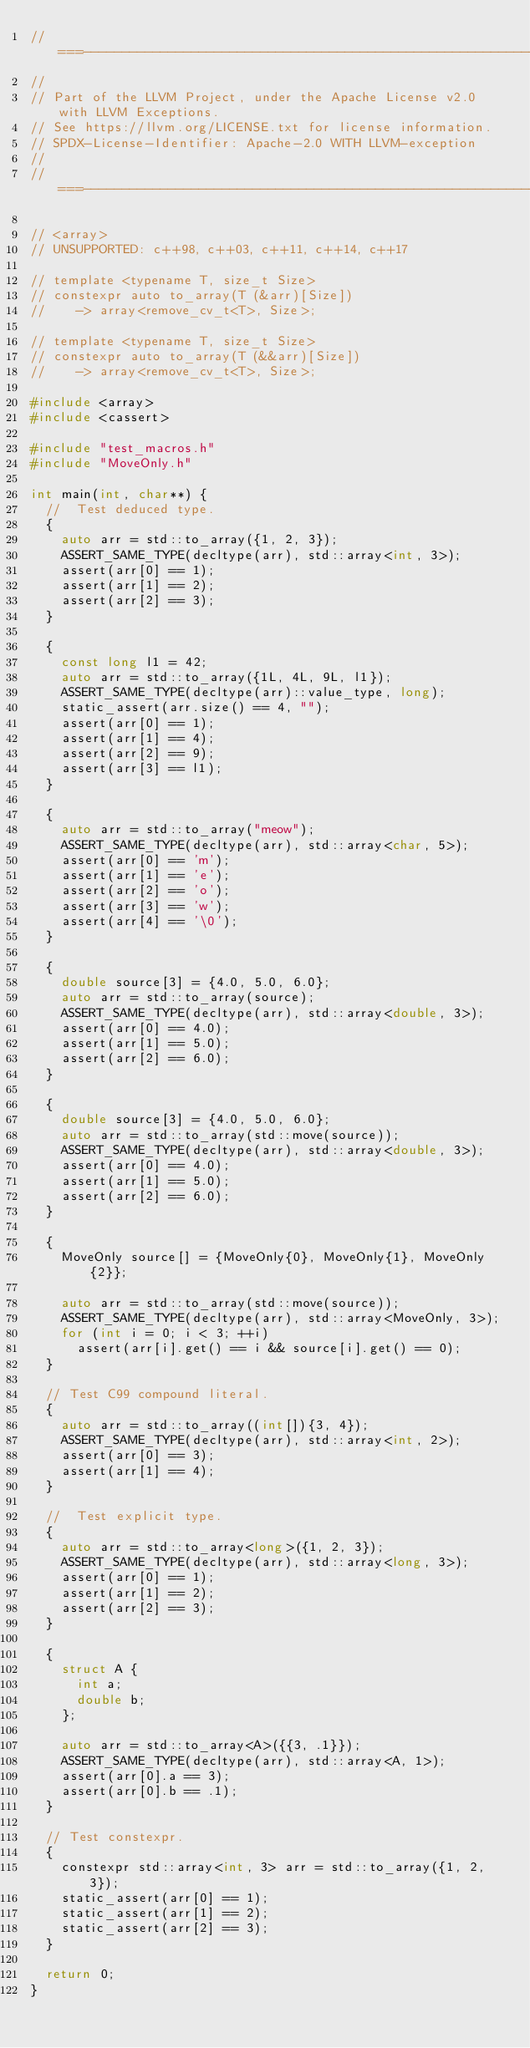Convert code to text. <code><loc_0><loc_0><loc_500><loc_500><_C++_>//===----------------------------------------------------------------------===//
//
// Part of the LLVM Project, under the Apache License v2.0 with LLVM Exceptions.
// See https://llvm.org/LICENSE.txt for license information.
// SPDX-License-Identifier: Apache-2.0 WITH LLVM-exception
//
//===----------------------------------------------------------------------===//

// <array>
// UNSUPPORTED: c++98, c++03, c++11, c++14, c++17

// template <typename T, size_t Size>
// constexpr auto to_array(T (&arr)[Size])
//    -> array<remove_cv_t<T>, Size>;

// template <typename T, size_t Size>
// constexpr auto to_array(T (&&arr)[Size])
//    -> array<remove_cv_t<T>, Size>;

#include <array>
#include <cassert>

#include "test_macros.h"
#include "MoveOnly.h"

int main(int, char**) {
  //  Test deduced type.
  {
    auto arr = std::to_array({1, 2, 3});
    ASSERT_SAME_TYPE(decltype(arr), std::array<int, 3>);
    assert(arr[0] == 1);
    assert(arr[1] == 2);
    assert(arr[2] == 3);
  }

  {
    const long l1 = 42;
    auto arr = std::to_array({1L, 4L, 9L, l1});
    ASSERT_SAME_TYPE(decltype(arr)::value_type, long);
    static_assert(arr.size() == 4, "");
    assert(arr[0] == 1);
    assert(arr[1] == 4);
    assert(arr[2] == 9);
    assert(arr[3] == l1);
  }

  {
    auto arr = std::to_array("meow");
    ASSERT_SAME_TYPE(decltype(arr), std::array<char, 5>);
    assert(arr[0] == 'm');
    assert(arr[1] == 'e');
    assert(arr[2] == 'o');
    assert(arr[3] == 'w');
    assert(arr[4] == '\0');
  }

  {
    double source[3] = {4.0, 5.0, 6.0};
    auto arr = std::to_array(source);
    ASSERT_SAME_TYPE(decltype(arr), std::array<double, 3>);
    assert(arr[0] == 4.0);
    assert(arr[1] == 5.0);
    assert(arr[2] == 6.0);
  }

  {
    double source[3] = {4.0, 5.0, 6.0};
    auto arr = std::to_array(std::move(source));
    ASSERT_SAME_TYPE(decltype(arr), std::array<double, 3>);
    assert(arr[0] == 4.0);
    assert(arr[1] == 5.0);
    assert(arr[2] == 6.0);
  }

  {
    MoveOnly source[] = {MoveOnly{0}, MoveOnly{1}, MoveOnly{2}};

    auto arr = std::to_array(std::move(source));
    ASSERT_SAME_TYPE(decltype(arr), std::array<MoveOnly, 3>);
    for (int i = 0; i < 3; ++i)
      assert(arr[i].get() == i && source[i].get() == 0);
  }

  // Test C99 compound literal.
  {
    auto arr = std::to_array((int[]){3, 4});
    ASSERT_SAME_TYPE(decltype(arr), std::array<int, 2>);
    assert(arr[0] == 3);
    assert(arr[1] == 4);
  }

  //  Test explicit type.
  {
    auto arr = std::to_array<long>({1, 2, 3});
    ASSERT_SAME_TYPE(decltype(arr), std::array<long, 3>);
    assert(arr[0] == 1);
    assert(arr[1] == 2);
    assert(arr[2] == 3);
  }

  {
    struct A {
      int a;
      double b;
    };

    auto arr = std::to_array<A>({{3, .1}});
    ASSERT_SAME_TYPE(decltype(arr), std::array<A, 1>);
    assert(arr[0].a == 3);
    assert(arr[0].b == .1);
  }

  // Test constexpr.
  {
    constexpr std::array<int, 3> arr = std::to_array({1, 2, 3});
    static_assert(arr[0] == 1);
    static_assert(arr[1] == 2);
    static_assert(arr[2] == 3);
  }

  return 0;
}
</code> 